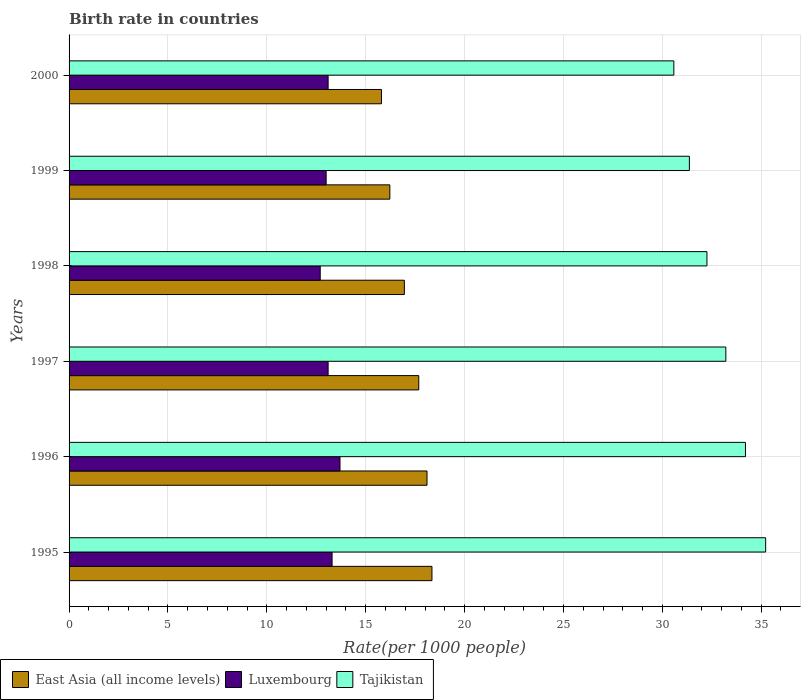Are the number of bars on each tick of the Y-axis equal?
Your answer should be compact. Yes. What is the label of the 6th group of bars from the top?
Your response must be concise. 1995. In how many cases, is the number of bars for a given year not equal to the number of legend labels?
Give a very brief answer. 0. What is the birth rate in East Asia (all income levels) in 1998?
Provide a short and direct response. 16.96. Across all years, what is the maximum birth rate in East Asia (all income levels)?
Make the answer very short. 18.35. Across all years, what is the minimum birth rate in Tajikistan?
Keep it short and to the point. 30.58. In which year was the birth rate in Luxembourg minimum?
Offer a very short reply. 1998. What is the total birth rate in Luxembourg in the graph?
Make the answer very short. 78.9. What is the difference between the birth rate in Tajikistan in 1996 and that in 2000?
Ensure brevity in your answer.  3.62. What is the difference between the birth rate in Luxembourg in 1997 and the birth rate in East Asia (all income levels) in 1998?
Provide a short and direct response. -3.86. What is the average birth rate in Luxembourg per year?
Provide a succinct answer. 13.15. In the year 1996, what is the difference between the birth rate in Luxembourg and birth rate in East Asia (all income levels)?
Ensure brevity in your answer.  -4.4. In how many years, is the birth rate in Luxembourg greater than 19 ?
Keep it short and to the point. 0. What is the ratio of the birth rate in East Asia (all income levels) in 1996 to that in 1999?
Provide a succinct answer. 1.12. Is the birth rate in Luxembourg in 1996 less than that in 1998?
Your answer should be very brief. No. What is the difference between the highest and the second highest birth rate in East Asia (all income levels)?
Provide a short and direct response. 0.25. What does the 3rd bar from the top in 2000 represents?
Keep it short and to the point. East Asia (all income levels). What does the 3rd bar from the bottom in 1996 represents?
Give a very brief answer. Tajikistan. How many years are there in the graph?
Keep it short and to the point. 6. Are the values on the major ticks of X-axis written in scientific E-notation?
Make the answer very short. No. Does the graph contain grids?
Make the answer very short. Yes. What is the title of the graph?
Offer a very short reply. Birth rate in countries. Does "Kuwait" appear as one of the legend labels in the graph?
Offer a terse response. No. What is the label or title of the X-axis?
Your answer should be very brief. Rate(per 1000 people). What is the label or title of the Y-axis?
Offer a terse response. Years. What is the Rate(per 1000 people) of East Asia (all income levels) in 1995?
Ensure brevity in your answer.  18.35. What is the Rate(per 1000 people) of Tajikistan in 1995?
Your answer should be compact. 35.23. What is the Rate(per 1000 people) in East Asia (all income levels) in 1996?
Provide a succinct answer. 18.1. What is the Rate(per 1000 people) in Tajikistan in 1996?
Offer a very short reply. 34.2. What is the Rate(per 1000 people) in East Asia (all income levels) in 1997?
Your answer should be compact. 17.68. What is the Rate(per 1000 people) in Tajikistan in 1997?
Keep it short and to the point. 33.21. What is the Rate(per 1000 people) of East Asia (all income levels) in 1998?
Give a very brief answer. 16.96. What is the Rate(per 1000 people) in Luxembourg in 1998?
Give a very brief answer. 12.7. What is the Rate(per 1000 people) in Tajikistan in 1998?
Provide a succinct answer. 32.26. What is the Rate(per 1000 people) of East Asia (all income levels) in 1999?
Your answer should be compact. 16.22. What is the Rate(per 1000 people) in Luxembourg in 1999?
Make the answer very short. 13. What is the Rate(per 1000 people) of Tajikistan in 1999?
Give a very brief answer. 31.37. What is the Rate(per 1000 people) in East Asia (all income levels) in 2000?
Make the answer very short. 15.8. What is the Rate(per 1000 people) of Luxembourg in 2000?
Give a very brief answer. 13.1. What is the Rate(per 1000 people) of Tajikistan in 2000?
Your response must be concise. 30.58. Across all years, what is the maximum Rate(per 1000 people) of East Asia (all income levels)?
Ensure brevity in your answer.  18.35. Across all years, what is the maximum Rate(per 1000 people) of Tajikistan?
Give a very brief answer. 35.23. Across all years, what is the minimum Rate(per 1000 people) of East Asia (all income levels)?
Your answer should be very brief. 15.8. Across all years, what is the minimum Rate(per 1000 people) in Tajikistan?
Your answer should be very brief. 30.58. What is the total Rate(per 1000 people) in East Asia (all income levels) in the graph?
Provide a short and direct response. 103.11. What is the total Rate(per 1000 people) in Luxembourg in the graph?
Offer a terse response. 78.9. What is the total Rate(per 1000 people) in Tajikistan in the graph?
Provide a succinct answer. 196.85. What is the difference between the Rate(per 1000 people) in Luxembourg in 1995 and that in 1996?
Provide a succinct answer. -0.4. What is the difference between the Rate(per 1000 people) of Tajikistan in 1995 and that in 1997?
Give a very brief answer. 2.01. What is the difference between the Rate(per 1000 people) in East Asia (all income levels) in 1995 and that in 1998?
Give a very brief answer. 1.4. What is the difference between the Rate(per 1000 people) of Luxembourg in 1995 and that in 1998?
Provide a succinct answer. 0.6. What is the difference between the Rate(per 1000 people) of Tajikistan in 1995 and that in 1998?
Provide a short and direct response. 2.97. What is the difference between the Rate(per 1000 people) in East Asia (all income levels) in 1995 and that in 1999?
Keep it short and to the point. 2.13. What is the difference between the Rate(per 1000 people) of Luxembourg in 1995 and that in 1999?
Give a very brief answer. 0.3. What is the difference between the Rate(per 1000 people) in Tajikistan in 1995 and that in 1999?
Make the answer very short. 3.86. What is the difference between the Rate(per 1000 people) in East Asia (all income levels) in 1995 and that in 2000?
Ensure brevity in your answer.  2.55. What is the difference between the Rate(per 1000 people) in Luxembourg in 1995 and that in 2000?
Offer a very short reply. 0.2. What is the difference between the Rate(per 1000 people) in Tajikistan in 1995 and that in 2000?
Make the answer very short. 4.64. What is the difference between the Rate(per 1000 people) in East Asia (all income levels) in 1996 and that in 1997?
Offer a terse response. 0.42. What is the difference between the Rate(per 1000 people) in Luxembourg in 1996 and that in 1997?
Provide a short and direct response. 0.6. What is the difference between the Rate(per 1000 people) in East Asia (all income levels) in 1996 and that in 1998?
Ensure brevity in your answer.  1.15. What is the difference between the Rate(per 1000 people) in Luxembourg in 1996 and that in 1998?
Provide a succinct answer. 1. What is the difference between the Rate(per 1000 people) of Tajikistan in 1996 and that in 1998?
Provide a short and direct response. 1.95. What is the difference between the Rate(per 1000 people) in East Asia (all income levels) in 1996 and that in 1999?
Your answer should be compact. 1.88. What is the difference between the Rate(per 1000 people) of Luxembourg in 1996 and that in 1999?
Provide a short and direct response. 0.7. What is the difference between the Rate(per 1000 people) in Tajikistan in 1996 and that in 1999?
Offer a very short reply. 2.84. What is the difference between the Rate(per 1000 people) in East Asia (all income levels) in 1996 and that in 2000?
Give a very brief answer. 2.3. What is the difference between the Rate(per 1000 people) of Luxembourg in 1996 and that in 2000?
Give a very brief answer. 0.6. What is the difference between the Rate(per 1000 people) in Tajikistan in 1996 and that in 2000?
Your response must be concise. 3.62. What is the difference between the Rate(per 1000 people) in East Asia (all income levels) in 1997 and that in 1998?
Provide a short and direct response. 0.73. What is the difference between the Rate(per 1000 people) of Tajikistan in 1997 and that in 1998?
Your answer should be compact. 0.95. What is the difference between the Rate(per 1000 people) in East Asia (all income levels) in 1997 and that in 1999?
Your answer should be compact. 1.46. What is the difference between the Rate(per 1000 people) of Luxembourg in 1997 and that in 1999?
Make the answer very short. 0.1. What is the difference between the Rate(per 1000 people) in Tajikistan in 1997 and that in 1999?
Give a very brief answer. 1.84. What is the difference between the Rate(per 1000 people) in East Asia (all income levels) in 1997 and that in 2000?
Provide a short and direct response. 1.89. What is the difference between the Rate(per 1000 people) in Tajikistan in 1997 and that in 2000?
Keep it short and to the point. 2.63. What is the difference between the Rate(per 1000 people) of East Asia (all income levels) in 1998 and that in 1999?
Your answer should be compact. 0.73. What is the difference between the Rate(per 1000 people) of Tajikistan in 1998 and that in 1999?
Provide a succinct answer. 0.89. What is the difference between the Rate(per 1000 people) of East Asia (all income levels) in 1998 and that in 2000?
Provide a succinct answer. 1.16. What is the difference between the Rate(per 1000 people) of Luxembourg in 1998 and that in 2000?
Offer a very short reply. -0.4. What is the difference between the Rate(per 1000 people) of Tajikistan in 1998 and that in 2000?
Offer a very short reply. 1.67. What is the difference between the Rate(per 1000 people) of East Asia (all income levels) in 1999 and that in 2000?
Offer a very short reply. 0.42. What is the difference between the Rate(per 1000 people) in Luxembourg in 1999 and that in 2000?
Offer a very short reply. -0.1. What is the difference between the Rate(per 1000 people) in Tajikistan in 1999 and that in 2000?
Ensure brevity in your answer.  0.79. What is the difference between the Rate(per 1000 people) in East Asia (all income levels) in 1995 and the Rate(per 1000 people) in Luxembourg in 1996?
Make the answer very short. 4.65. What is the difference between the Rate(per 1000 people) of East Asia (all income levels) in 1995 and the Rate(per 1000 people) of Tajikistan in 1996?
Ensure brevity in your answer.  -15.85. What is the difference between the Rate(per 1000 people) in Luxembourg in 1995 and the Rate(per 1000 people) in Tajikistan in 1996?
Offer a very short reply. -20.91. What is the difference between the Rate(per 1000 people) of East Asia (all income levels) in 1995 and the Rate(per 1000 people) of Luxembourg in 1997?
Your response must be concise. 5.25. What is the difference between the Rate(per 1000 people) of East Asia (all income levels) in 1995 and the Rate(per 1000 people) of Tajikistan in 1997?
Your answer should be compact. -14.86. What is the difference between the Rate(per 1000 people) in Luxembourg in 1995 and the Rate(per 1000 people) in Tajikistan in 1997?
Offer a terse response. -19.91. What is the difference between the Rate(per 1000 people) of East Asia (all income levels) in 1995 and the Rate(per 1000 people) of Luxembourg in 1998?
Offer a terse response. 5.65. What is the difference between the Rate(per 1000 people) in East Asia (all income levels) in 1995 and the Rate(per 1000 people) in Tajikistan in 1998?
Your answer should be compact. -13.91. What is the difference between the Rate(per 1000 people) in Luxembourg in 1995 and the Rate(per 1000 people) in Tajikistan in 1998?
Ensure brevity in your answer.  -18.96. What is the difference between the Rate(per 1000 people) in East Asia (all income levels) in 1995 and the Rate(per 1000 people) in Luxembourg in 1999?
Offer a very short reply. 5.35. What is the difference between the Rate(per 1000 people) in East Asia (all income levels) in 1995 and the Rate(per 1000 people) in Tajikistan in 1999?
Provide a short and direct response. -13.02. What is the difference between the Rate(per 1000 people) in Luxembourg in 1995 and the Rate(per 1000 people) in Tajikistan in 1999?
Your answer should be compact. -18.07. What is the difference between the Rate(per 1000 people) in East Asia (all income levels) in 1995 and the Rate(per 1000 people) in Luxembourg in 2000?
Ensure brevity in your answer.  5.25. What is the difference between the Rate(per 1000 people) in East Asia (all income levels) in 1995 and the Rate(per 1000 people) in Tajikistan in 2000?
Your answer should be compact. -12.23. What is the difference between the Rate(per 1000 people) of Luxembourg in 1995 and the Rate(per 1000 people) of Tajikistan in 2000?
Your answer should be compact. -17.28. What is the difference between the Rate(per 1000 people) of East Asia (all income levels) in 1996 and the Rate(per 1000 people) of Luxembourg in 1997?
Make the answer very short. 5. What is the difference between the Rate(per 1000 people) of East Asia (all income levels) in 1996 and the Rate(per 1000 people) of Tajikistan in 1997?
Your response must be concise. -15.11. What is the difference between the Rate(per 1000 people) of Luxembourg in 1996 and the Rate(per 1000 people) of Tajikistan in 1997?
Provide a succinct answer. -19.51. What is the difference between the Rate(per 1000 people) of East Asia (all income levels) in 1996 and the Rate(per 1000 people) of Luxembourg in 1998?
Your answer should be compact. 5.4. What is the difference between the Rate(per 1000 people) in East Asia (all income levels) in 1996 and the Rate(per 1000 people) in Tajikistan in 1998?
Provide a short and direct response. -14.16. What is the difference between the Rate(per 1000 people) of Luxembourg in 1996 and the Rate(per 1000 people) of Tajikistan in 1998?
Offer a very short reply. -18.56. What is the difference between the Rate(per 1000 people) of East Asia (all income levels) in 1996 and the Rate(per 1000 people) of Luxembourg in 1999?
Give a very brief answer. 5.1. What is the difference between the Rate(per 1000 people) of East Asia (all income levels) in 1996 and the Rate(per 1000 people) of Tajikistan in 1999?
Ensure brevity in your answer.  -13.27. What is the difference between the Rate(per 1000 people) of Luxembourg in 1996 and the Rate(per 1000 people) of Tajikistan in 1999?
Offer a very short reply. -17.67. What is the difference between the Rate(per 1000 people) in East Asia (all income levels) in 1996 and the Rate(per 1000 people) in Luxembourg in 2000?
Provide a succinct answer. 5. What is the difference between the Rate(per 1000 people) of East Asia (all income levels) in 1996 and the Rate(per 1000 people) of Tajikistan in 2000?
Offer a terse response. -12.48. What is the difference between the Rate(per 1000 people) of Luxembourg in 1996 and the Rate(per 1000 people) of Tajikistan in 2000?
Provide a succinct answer. -16.88. What is the difference between the Rate(per 1000 people) of East Asia (all income levels) in 1997 and the Rate(per 1000 people) of Luxembourg in 1998?
Give a very brief answer. 4.98. What is the difference between the Rate(per 1000 people) of East Asia (all income levels) in 1997 and the Rate(per 1000 people) of Tajikistan in 1998?
Make the answer very short. -14.57. What is the difference between the Rate(per 1000 people) in Luxembourg in 1997 and the Rate(per 1000 people) in Tajikistan in 1998?
Keep it short and to the point. -19.16. What is the difference between the Rate(per 1000 people) of East Asia (all income levels) in 1997 and the Rate(per 1000 people) of Luxembourg in 1999?
Your response must be concise. 4.68. What is the difference between the Rate(per 1000 people) in East Asia (all income levels) in 1997 and the Rate(per 1000 people) in Tajikistan in 1999?
Offer a terse response. -13.68. What is the difference between the Rate(per 1000 people) in Luxembourg in 1997 and the Rate(per 1000 people) in Tajikistan in 1999?
Offer a very short reply. -18.27. What is the difference between the Rate(per 1000 people) of East Asia (all income levels) in 1997 and the Rate(per 1000 people) of Luxembourg in 2000?
Offer a terse response. 4.58. What is the difference between the Rate(per 1000 people) of East Asia (all income levels) in 1997 and the Rate(per 1000 people) of Tajikistan in 2000?
Provide a short and direct response. -12.9. What is the difference between the Rate(per 1000 people) of Luxembourg in 1997 and the Rate(per 1000 people) of Tajikistan in 2000?
Make the answer very short. -17.48. What is the difference between the Rate(per 1000 people) of East Asia (all income levels) in 1998 and the Rate(per 1000 people) of Luxembourg in 1999?
Your answer should be compact. 3.96. What is the difference between the Rate(per 1000 people) of East Asia (all income levels) in 1998 and the Rate(per 1000 people) of Tajikistan in 1999?
Give a very brief answer. -14.41. What is the difference between the Rate(per 1000 people) of Luxembourg in 1998 and the Rate(per 1000 people) of Tajikistan in 1999?
Make the answer very short. -18.67. What is the difference between the Rate(per 1000 people) of East Asia (all income levels) in 1998 and the Rate(per 1000 people) of Luxembourg in 2000?
Offer a very short reply. 3.86. What is the difference between the Rate(per 1000 people) in East Asia (all income levels) in 1998 and the Rate(per 1000 people) in Tajikistan in 2000?
Your answer should be compact. -13.63. What is the difference between the Rate(per 1000 people) in Luxembourg in 1998 and the Rate(per 1000 people) in Tajikistan in 2000?
Provide a succinct answer. -17.88. What is the difference between the Rate(per 1000 people) in East Asia (all income levels) in 1999 and the Rate(per 1000 people) in Luxembourg in 2000?
Your response must be concise. 3.12. What is the difference between the Rate(per 1000 people) of East Asia (all income levels) in 1999 and the Rate(per 1000 people) of Tajikistan in 2000?
Keep it short and to the point. -14.36. What is the difference between the Rate(per 1000 people) of Luxembourg in 1999 and the Rate(per 1000 people) of Tajikistan in 2000?
Your answer should be very brief. -17.58. What is the average Rate(per 1000 people) of East Asia (all income levels) per year?
Keep it short and to the point. 17.18. What is the average Rate(per 1000 people) in Luxembourg per year?
Provide a succinct answer. 13.15. What is the average Rate(per 1000 people) in Tajikistan per year?
Provide a short and direct response. 32.81. In the year 1995, what is the difference between the Rate(per 1000 people) of East Asia (all income levels) and Rate(per 1000 people) of Luxembourg?
Make the answer very short. 5.05. In the year 1995, what is the difference between the Rate(per 1000 people) of East Asia (all income levels) and Rate(per 1000 people) of Tajikistan?
Your answer should be very brief. -16.88. In the year 1995, what is the difference between the Rate(per 1000 people) of Luxembourg and Rate(per 1000 people) of Tajikistan?
Your response must be concise. -21.93. In the year 1996, what is the difference between the Rate(per 1000 people) of East Asia (all income levels) and Rate(per 1000 people) of Luxembourg?
Provide a short and direct response. 4.4. In the year 1996, what is the difference between the Rate(per 1000 people) of East Asia (all income levels) and Rate(per 1000 people) of Tajikistan?
Your answer should be very brief. -16.1. In the year 1996, what is the difference between the Rate(per 1000 people) of Luxembourg and Rate(per 1000 people) of Tajikistan?
Keep it short and to the point. -20.5. In the year 1997, what is the difference between the Rate(per 1000 people) in East Asia (all income levels) and Rate(per 1000 people) in Luxembourg?
Offer a terse response. 4.58. In the year 1997, what is the difference between the Rate(per 1000 people) of East Asia (all income levels) and Rate(per 1000 people) of Tajikistan?
Make the answer very short. -15.53. In the year 1997, what is the difference between the Rate(per 1000 people) of Luxembourg and Rate(per 1000 people) of Tajikistan?
Provide a succinct answer. -20.11. In the year 1998, what is the difference between the Rate(per 1000 people) of East Asia (all income levels) and Rate(per 1000 people) of Luxembourg?
Provide a succinct answer. 4.26. In the year 1998, what is the difference between the Rate(per 1000 people) in East Asia (all income levels) and Rate(per 1000 people) in Tajikistan?
Give a very brief answer. -15.3. In the year 1998, what is the difference between the Rate(per 1000 people) of Luxembourg and Rate(per 1000 people) of Tajikistan?
Offer a very short reply. -19.56. In the year 1999, what is the difference between the Rate(per 1000 people) of East Asia (all income levels) and Rate(per 1000 people) of Luxembourg?
Ensure brevity in your answer.  3.22. In the year 1999, what is the difference between the Rate(per 1000 people) in East Asia (all income levels) and Rate(per 1000 people) in Tajikistan?
Your answer should be compact. -15.15. In the year 1999, what is the difference between the Rate(per 1000 people) in Luxembourg and Rate(per 1000 people) in Tajikistan?
Keep it short and to the point. -18.37. In the year 2000, what is the difference between the Rate(per 1000 people) in East Asia (all income levels) and Rate(per 1000 people) in Luxembourg?
Keep it short and to the point. 2.7. In the year 2000, what is the difference between the Rate(per 1000 people) in East Asia (all income levels) and Rate(per 1000 people) in Tajikistan?
Make the answer very short. -14.79. In the year 2000, what is the difference between the Rate(per 1000 people) in Luxembourg and Rate(per 1000 people) in Tajikistan?
Ensure brevity in your answer.  -17.48. What is the ratio of the Rate(per 1000 people) in East Asia (all income levels) in 1995 to that in 1996?
Offer a terse response. 1.01. What is the ratio of the Rate(per 1000 people) in Luxembourg in 1995 to that in 1996?
Your answer should be very brief. 0.97. What is the ratio of the Rate(per 1000 people) of Tajikistan in 1995 to that in 1996?
Offer a terse response. 1.03. What is the ratio of the Rate(per 1000 people) in East Asia (all income levels) in 1995 to that in 1997?
Offer a very short reply. 1.04. What is the ratio of the Rate(per 1000 people) in Luxembourg in 1995 to that in 1997?
Your response must be concise. 1.02. What is the ratio of the Rate(per 1000 people) of Tajikistan in 1995 to that in 1997?
Keep it short and to the point. 1.06. What is the ratio of the Rate(per 1000 people) in East Asia (all income levels) in 1995 to that in 1998?
Your answer should be very brief. 1.08. What is the ratio of the Rate(per 1000 people) in Luxembourg in 1995 to that in 1998?
Offer a terse response. 1.05. What is the ratio of the Rate(per 1000 people) of Tajikistan in 1995 to that in 1998?
Provide a succinct answer. 1.09. What is the ratio of the Rate(per 1000 people) of East Asia (all income levels) in 1995 to that in 1999?
Keep it short and to the point. 1.13. What is the ratio of the Rate(per 1000 people) of Luxembourg in 1995 to that in 1999?
Provide a short and direct response. 1.02. What is the ratio of the Rate(per 1000 people) in Tajikistan in 1995 to that in 1999?
Provide a succinct answer. 1.12. What is the ratio of the Rate(per 1000 people) in East Asia (all income levels) in 1995 to that in 2000?
Give a very brief answer. 1.16. What is the ratio of the Rate(per 1000 people) in Luxembourg in 1995 to that in 2000?
Ensure brevity in your answer.  1.02. What is the ratio of the Rate(per 1000 people) of Tajikistan in 1995 to that in 2000?
Keep it short and to the point. 1.15. What is the ratio of the Rate(per 1000 people) in East Asia (all income levels) in 1996 to that in 1997?
Your answer should be compact. 1.02. What is the ratio of the Rate(per 1000 people) of Luxembourg in 1996 to that in 1997?
Make the answer very short. 1.05. What is the ratio of the Rate(per 1000 people) in Tajikistan in 1996 to that in 1997?
Provide a succinct answer. 1.03. What is the ratio of the Rate(per 1000 people) in East Asia (all income levels) in 1996 to that in 1998?
Your response must be concise. 1.07. What is the ratio of the Rate(per 1000 people) in Luxembourg in 1996 to that in 1998?
Provide a succinct answer. 1.08. What is the ratio of the Rate(per 1000 people) in Tajikistan in 1996 to that in 1998?
Your response must be concise. 1.06. What is the ratio of the Rate(per 1000 people) of East Asia (all income levels) in 1996 to that in 1999?
Offer a very short reply. 1.12. What is the ratio of the Rate(per 1000 people) of Luxembourg in 1996 to that in 1999?
Your answer should be compact. 1.05. What is the ratio of the Rate(per 1000 people) in Tajikistan in 1996 to that in 1999?
Your response must be concise. 1.09. What is the ratio of the Rate(per 1000 people) of East Asia (all income levels) in 1996 to that in 2000?
Your response must be concise. 1.15. What is the ratio of the Rate(per 1000 people) of Luxembourg in 1996 to that in 2000?
Your answer should be compact. 1.05. What is the ratio of the Rate(per 1000 people) in Tajikistan in 1996 to that in 2000?
Make the answer very short. 1.12. What is the ratio of the Rate(per 1000 people) in East Asia (all income levels) in 1997 to that in 1998?
Offer a very short reply. 1.04. What is the ratio of the Rate(per 1000 people) of Luxembourg in 1997 to that in 1998?
Provide a short and direct response. 1.03. What is the ratio of the Rate(per 1000 people) in Tajikistan in 1997 to that in 1998?
Ensure brevity in your answer.  1.03. What is the ratio of the Rate(per 1000 people) of East Asia (all income levels) in 1997 to that in 1999?
Offer a terse response. 1.09. What is the ratio of the Rate(per 1000 people) of Luxembourg in 1997 to that in 1999?
Ensure brevity in your answer.  1.01. What is the ratio of the Rate(per 1000 people) of Tajikistan in 1997 to that in 1999?
Provide a succinct answer. 1.06. What is the ratio of the Rate(per 1000 people) in East Asia (all income levels) in 1997 to that in 2000?
Your answer should be compact. 1.12. What is the ratio of the Rate(per 1000 people) of Luxembourg in 1997 to that in 2000?
Your answer should be compact. 1. What is the ratio of the Rate(per 1000 people) in Tajikistan in 1997 to that in 2000?
Provide a succinct answer. 1.09. What is the ratio of the Rate(per 1000 people) in East Asia (all income levels) in 1998 to that in 1999?
Make the answer very short. 1.05. What is the ratio of the Rate(per 1000 people) of Luxembourg in 1998 to that in 1999?
Provide a short and direct response. 0.98. What is the ratio of the Rate(per 1000 people) of Tajikistan in 1998 to that in 1999?
Make the answer very short. 1.03. What is the ratio of the Rate(per 1000 people) in East Asia (all income levels) in 1998 to that in 2000?
Your response must be concise. 1.07. What is the ratio of the Rate(per 1000 people) in Luxembourg in 1998 to that in 2000?
Your answer should be compact. 0.97. What is the ratio of the Rate(per 1000 people) in Tajikistan in 1998 to that in 2000?
Make the answer very short. 1.05. What is the ratio of the Rate(per 1000 people) of East Asia (all income levels) in 1999 to that in 2000?
Keep it short and to the point. 1.03. What is the ratio of the Rate(per 1000 people) in Tajikistan in 1999 to that in 2000?
Your response must be concise. 1.03. What is the difference between the highest and the second highest Rate(per 1000 people) in East Asia (all income levels)?
Make the answer very short. 0.25. What is the difference between the highest and the second highest Rate(per 1000 people) of Luxembourg?
Your answer should be very brief. 0.4. What is the difference between the highest and the lowest Rate(per 1000 people) in East Asia (all income levels)?
Ensure brevity in your answer.  2.55. What is the difference between the highest and the lowest Rate(per 1000 people) of Luxembourg?
Your answer should be compact. 1. What is the difference between the highest and the lowest Rate(per 1000 people) in Tajikistan?
Ensure brevity in your answer.  4.64. 